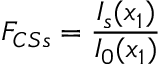<formula> <loc_0><loc_0><loc_500><loc_500>F _ { C S s } = \frac { I _ { s } ( x _ { 1 } ) } { I _ { 0 } ( x _ { 1 } ) }</formula> 